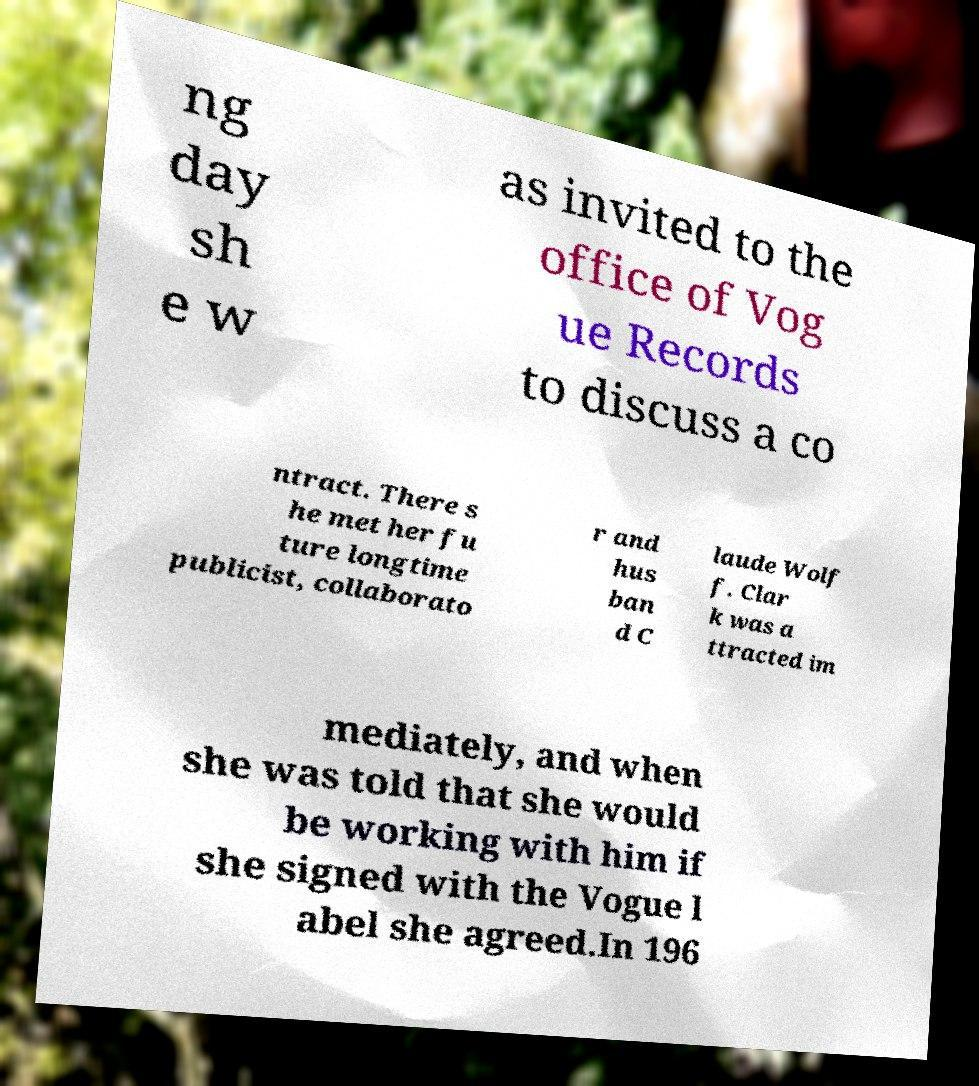Can you accurately transcribe the text from the provided image for me? ng day sh e w as invited to the office of Vog ue Records to discuss a co ntract. There s he met her fu ture longtime publicist, collaborato r and hus ban d C laude Wolf f. Clar k was a ttracted im mediately, and when she was told that she would be working with him if she signed with the Vogue l abel she agreed.In 196 